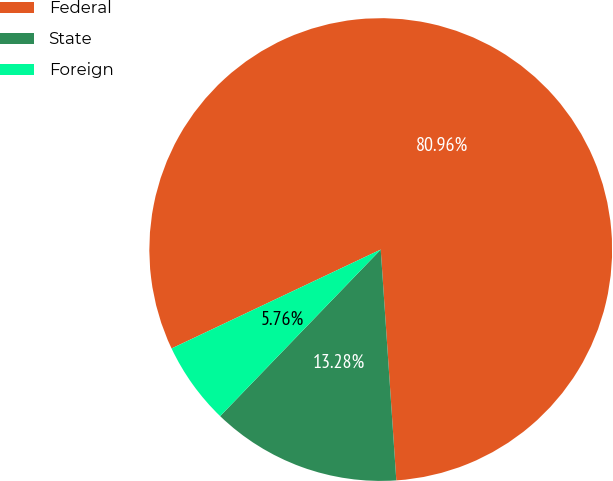Convert chart. <chart><loc_0><loc_0><loc_500><loc_500><pie_chart><fcel>Federal<fcel>State<fcel>Foreign<nl><fcel>80.95%<fcel>13.28%<fcel>5.76%<nl></chart> 